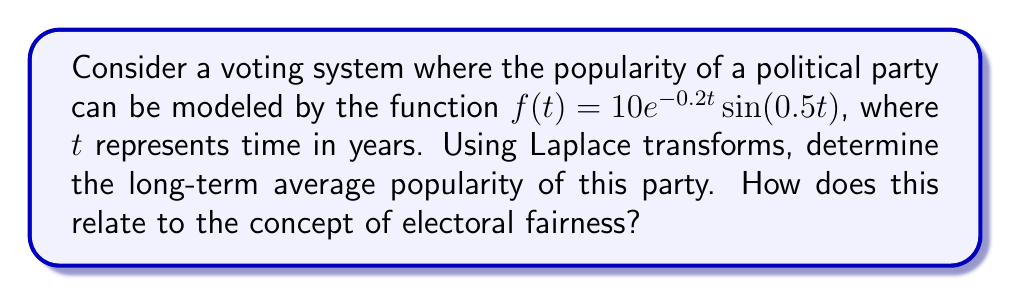Provide a solution to this math problem. To solve this problem, we'll use the following steps:

1) First, we need to find the Laplace transform of $f(t)$. The Laplace transform of $f(t) = 10e^{-0.2t}\sin(0.5t)$ is:

   $$F(s) = \mathcal{L}\{f(t)\} = \frac{10 \cdot 0.5}{(s+0.2)^2 + 0.5^2}$$

2) The Final Value Theorem states that for a function $f(t)$ with Laplace transform $F(s)$:

   $$\lim_{t \to \infty} f(t) = \lim_{s \to 0} sF(s)$$

   This theorem gives us the long-term average of the function.

3) Applying the Final Value Theorem:

   $$\lim_{t \to \infty} f(t) = \lim_{s \to 0} s \cdot \frac{10 \cdot 0.5}{(s+0.2)^2 + 0.5^2}$$

4) Simplifying:

   $$\lim_{s \to 0} \frac{5s}{(s+0.2)^2 + 0.25} = \frac{5 \cdot 0}{(0+0.2)^2 + 0.25} = 0$$

5) Therefore, the long-term average popularity of the party is 0.

This result relates to electoral fairness in that it shows the party's popularity oscillates but averages to zero over time. In a fair electoral system, this would suggest that no single party maintains dominance indefinitely, allowing for alternation of power which is a key aspect of democratic fairness.
Answer: The long-term average popularity of the party is 0, indicating that in a fair system, the party's influence balances out over time, supporting the concept of electoral fairness. 